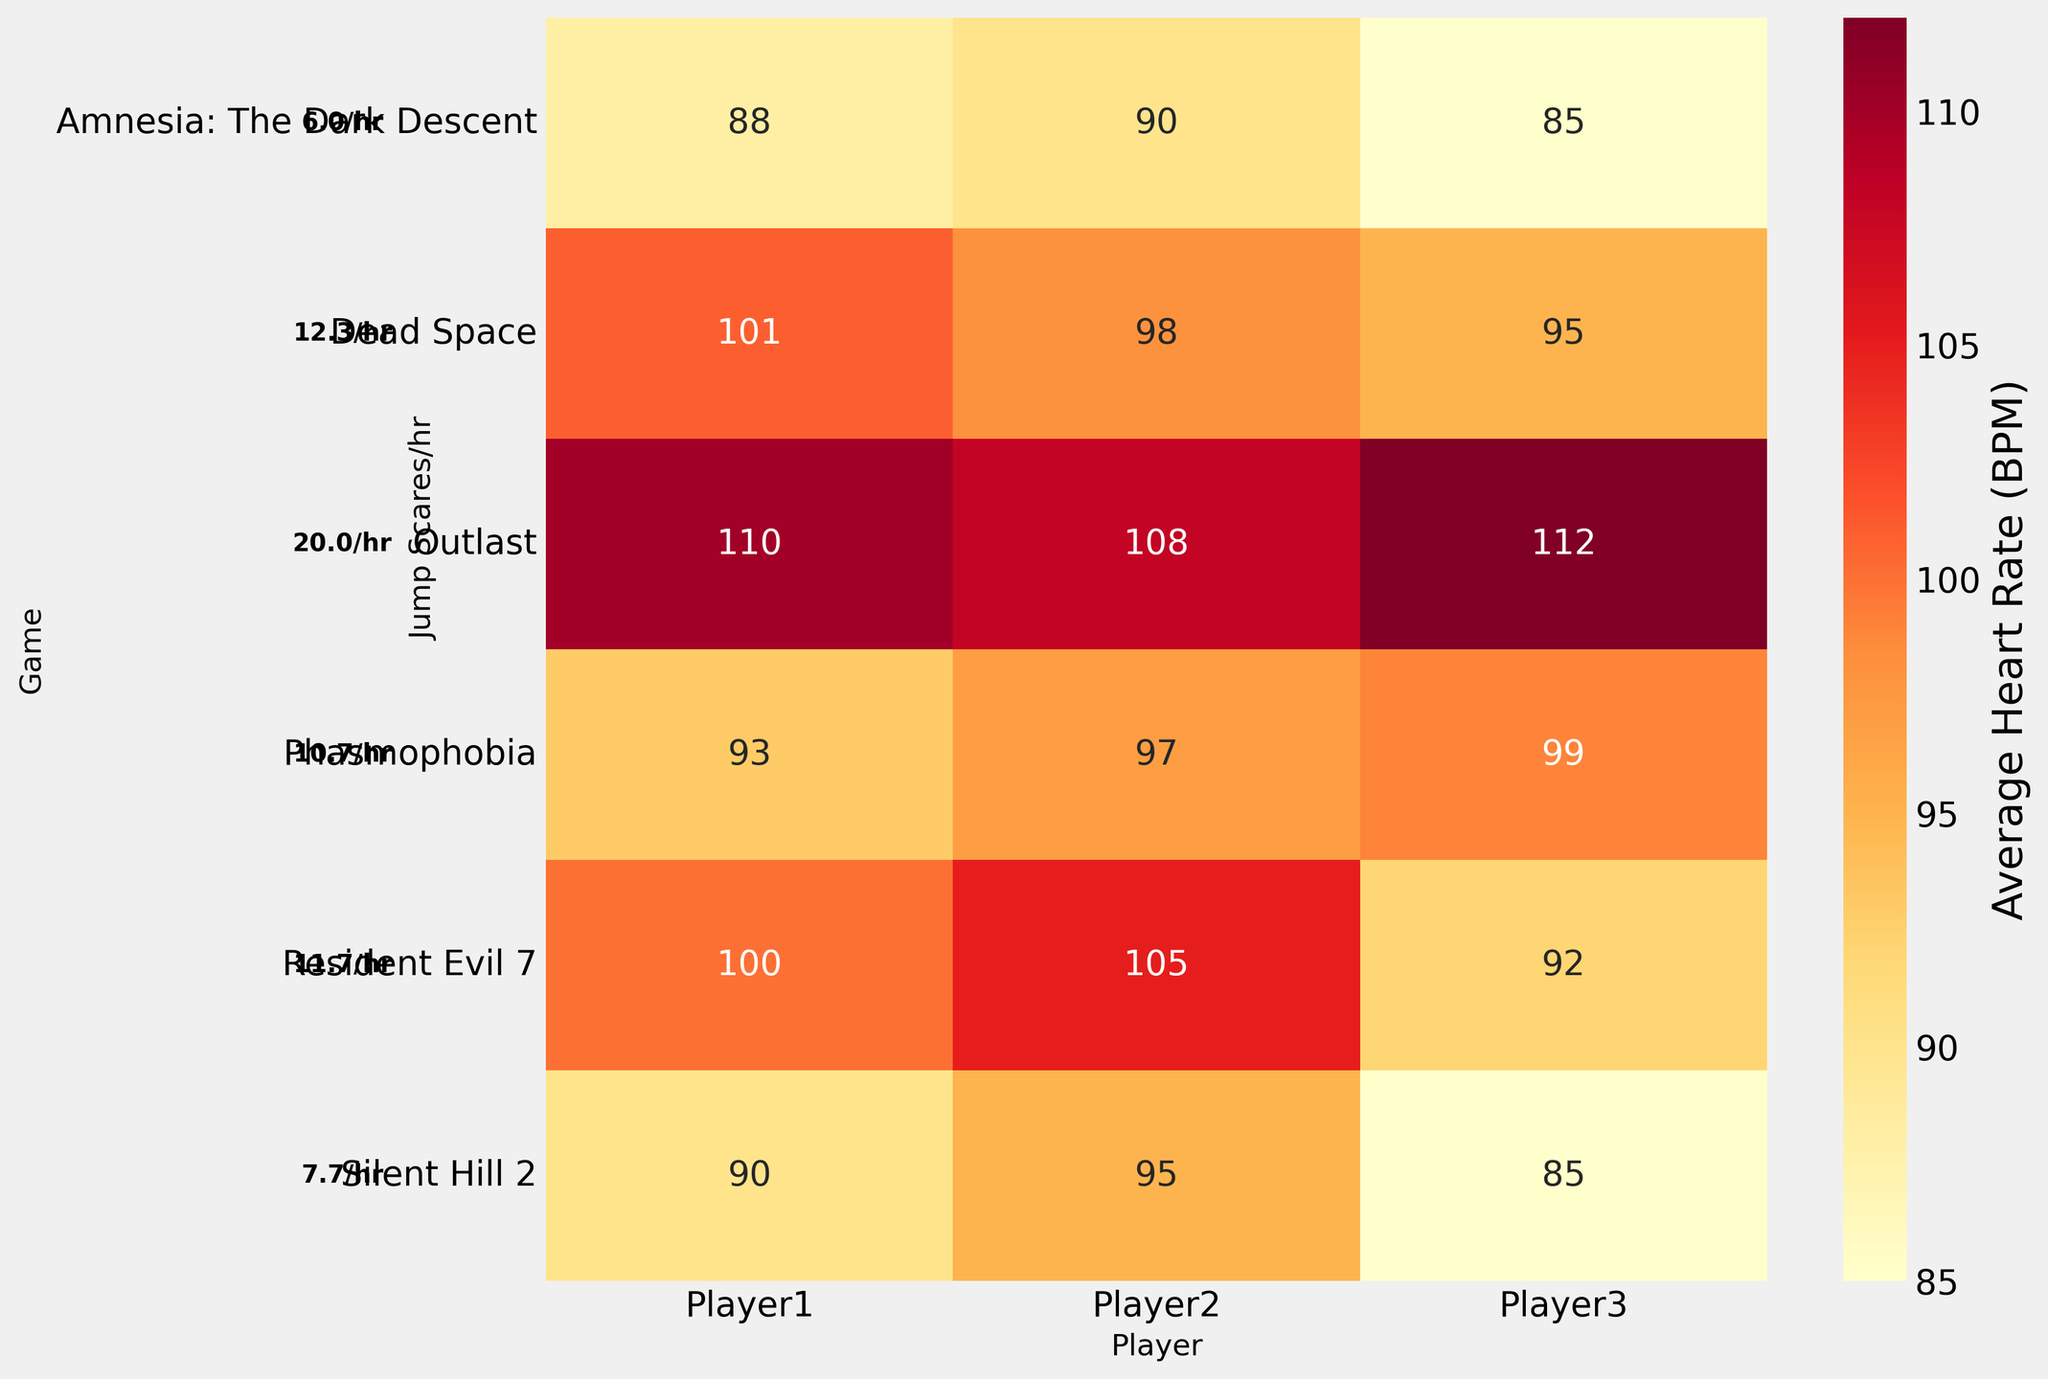What's the title of the figure? The title of the figure is usually displayed prominently at the top of the plot. For this figure, it is "Player Heart Rate vs. Jump Scare Frequency in Horror Games".
Answer: Player Heart Rate vs. Jump Scare Frequency in Horror Games What is the color range used in the heatmap? The color range in the heatmap represents different values, usually different colors indicating different heart rates in BPM. In this figure, a gradient from yellow to red (YlOrRd) is used.
Answer: Yellow to Red Which game has the highest average jump scare frequency? Look at the jump scare frequencies added as text beside each game. The highest number displayed is 20.0/hr. The game with this frequency is "Outlast."
Answer: Outlast What is the average heart rate of Player2 while playing Resident Evil 7? Locate Resident Evil 7 on the y-axis and Player2 on the x-axis, then find the intersecting cell. The number in the cell is the average heart rate. Here, it is 105 BPM.
Answer: 105 BPM Is there a significant difference in the heart rates of Player1 and Player2 for "Outlast"? Compare the values for Player1 and Player2 in the row corresponding to "Outlast". The heart rates are 110 BPM and 108 BPM respectively. The difference is 110 - 108 = 2 BPM, which is minor.
Answer: No significant difference How many games have an average heart rate above 100 BPM for any player? Go through each row and check if any cell has a heart rate value above 100 BPM. Outlast, Resident Evil 7, and Dead Space have values above 100 for at least one player. Count the number of such games.
Answer: 3 games Which player has the least variability in heart rate across all games? To find the player with the least variability, observe the cells for each player. Calculate the range (max - min) for each player:
- Player1: 20 (110 - 90)
- Player2: 17 (108 - 95)
- Player3: 27 (112 - 85)
Player2 has the least variability of 17 BPM.
Answer: Player2 What's the average heart rate of Player3 across all games? Add up the heart rate values for Player3 across all games and divide by the number of games:
(85 + 92 + 112 + 85 + 95 + 99) / 6 = 568 / 6 = 94.67 BPM
Answer: 94.67 BPM Which game shows the smallest jump scare frequency? Check the frequencies displayed beside each game. The smallest frequency is 6.0/hr for "Amnesia: The Dark Descent".
Answer: Amnesia: The Dark Descent What is the correlation between jump scare frequency and average heart rate? By visual inspection of the heatmap and the added jump scare frequency text, higher jump scare frequencies generally coincide with higher heart rates. Therefore, there is a positive correlation.
Answer: Positive correlation 